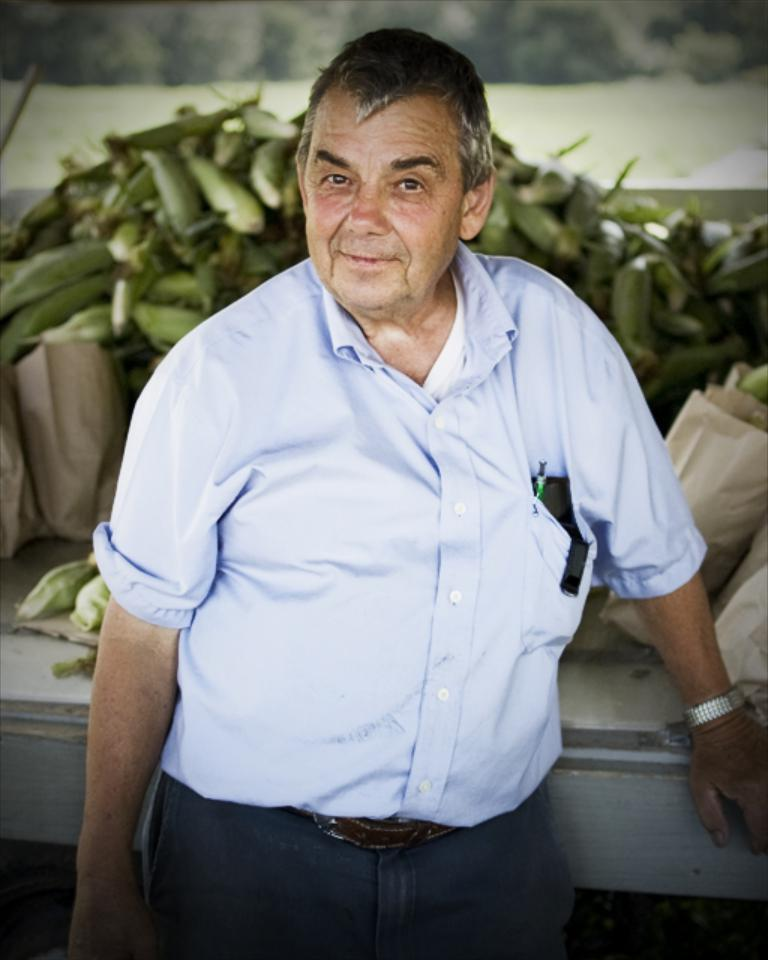What is the man in the image doing? The man is standing in the image. What is the man's facial expression in the image? The man is smiling in the image. What type of clothing is the man wearing? The man is wearing a shirt and a pair of pants in the image. What accessory is the man wearing? The man is wearing a belt in the image. What can be seen in the background of the image? There are bags and other items on a white surface in the background of the image. What type of sign can be seen in the image? There is no sign present in the image. What is the man eating for lunch in the image? There is no lunch or food visible in the image. 